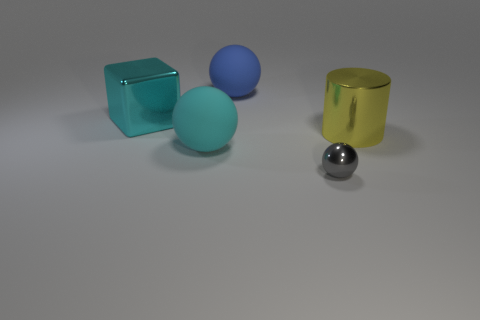Add 2 gray blocks. How many objects exist? 7 Subtract 0 blue cylinders. How many objects are left? 5 Subtract all balls. How many objects are left? 2 Subtract 1 spheres. How many spheres are left? 2 Subtract all green cylinders. Subtract all red balls. How many cylinders are left? 1 Subtract all green cylinders. How many brown spheres are left? 0 Subtract all big brown matte things. Subtract all blue things. How many objects are left? 4 Add 3 cyan things. How many cyan things are left? 5 Add 4 yellow objects. How many yellow objects exist? 5 Subtract all big blue matte balls. How many balls are left? 2 